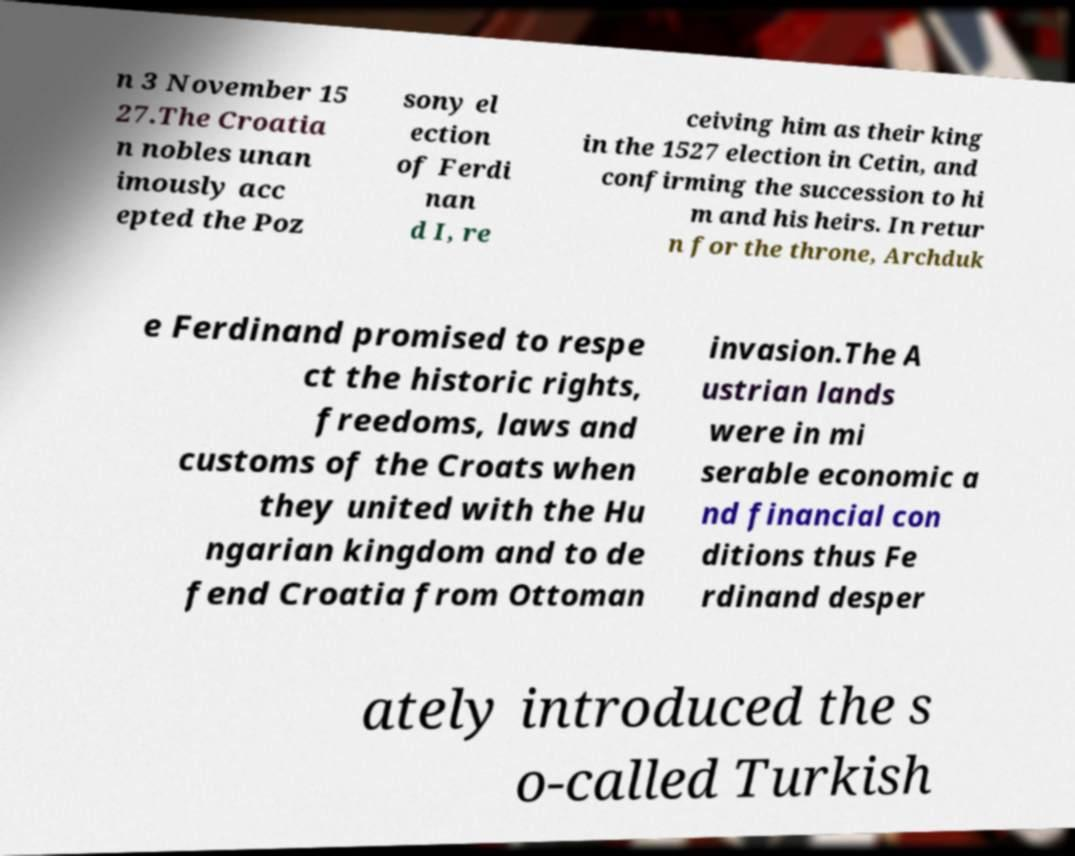Could you extract and type out the text from this image? n 3 November 15 27.The Croatia n nobles unan imously acc epted the Poz sony el ection of Ferdi nan d I, re ceiving him as their king in the 1527 election in Cetin, and confirming the succession to hi m and his heirs. In retur n for the throne, Archduk e Ferdinand promised to respe ct the historic rights, freedoms, laws and customs of the Croats when they united with the Hu ngarian kingdom and to de fend Croatia from Ottoman invasion.The A ustrian lands were in mi serable economic a nd financial con ditions thus Fe rdinand desper ately introduced the s o-called Turkish 